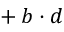<formula> <loc_0><loc_0><loc_500><loc_500>{ } + b \cdot d</formula> 